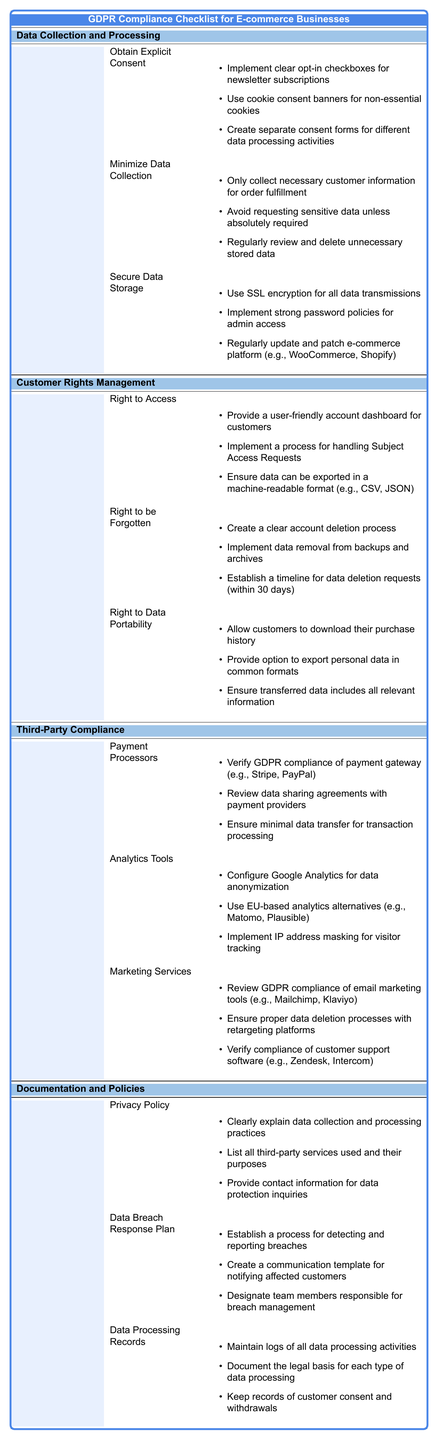What is one item listed under "Obtain Explicit Consent"? Looking under the "Data Collection and Processing" section, one of the bullet points under "Obtain Explicit Consent" is "Implement clear opt-in checkboxes for newsletter subscriptions."
Answer: Implement clear opt-in checkboxes for newsletter subscriptions How many items are listed under "Secure Data Storage"? In the section "Secure Data Storage," there are three items: "Use SSL encryption for all data transmissions," "Implement strong password policies for admin access," and "Regularly update and patch e-commerce platform (e.g., WooCommerce, Shopify)." Thus, the count is 3.
Answer: 3 Is "Data Processing Records" part of the "Documentation and Policies" section? Yes, "Data Processing Records" is mentioned in the table under the "Documentation and Policies" section.
Answer: Yes What are the first two items under "Right to be Forgotten"? Under "Right to be Forgotten," the first two items are "Create a clear account deletion process" and "Implement data removal from backups and archives."
Answer: Create a clear account deletion process, Implement data removal from backups and archives What actions should be taken regarding payment processors to ensure GDPR compliance? The actions include verifying GDPR compliance of payment gateways, reviewing data sharing agreements with payment providers, and ensuring minimal data transfer for transaction processing.
Answer: Verify compliance, review agreements, ensure minimal data transfer What are the total number of rights listed under the "Customer Rights Management" section? There are three rights listed: "Right to Access," "Right to be Forgotten," and "Right to Data Portability." This totals to 3 rights.
Answer: 3 According to the table, which section contains guidelines related to monitoring data breaches? The guidelines for monitoring data breaches can be found under "Data Breach Response Plan" in the "Documentation and Policies" section.
Answer: Data Breach Response Plan How many total action points could be taken under "Privacy Policy" according to this checklist? Under "Privacy Policy", there are three action points: "Clearly explain data collection and processing practices," "List all third-party services used and their purposes," and "Provide contact information for data protection inquiries." Therefore, the total is 3.
Answer: 3 Which compliance category addresses the use of analytics tools? The "Third-Party Compliance" category addresses the use of analytics tools.
Answer: Third-Party Compliance What is required to fulfill the "Right to Data Portability"? To fulfill the "Right to Data Portability," actions include allowing customers to download their purchase history, providing options to export personal data in common formats, and ensuring transferred data includes all relevant information.
Answer: Download purchase history, export personal data, ensure relevant information 